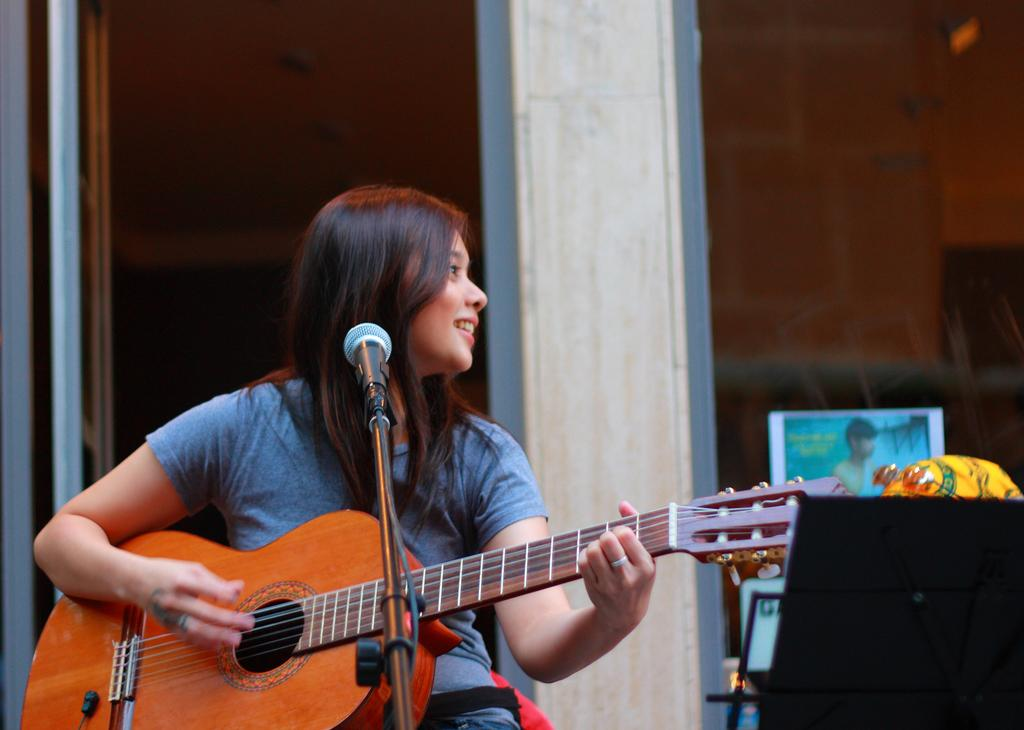Who is the main subject in the image? There is a woman in the image. What is the woman doing in the image? The woman is playing a guitar. What object is in front of the woman? There is a microphone in front of the woman. What expression does the woman have in the image? The woman is smiling. What type of skin condition can be seen on the woman's face in the image? There is no indication of any skin condition on the woman's face in the image. Can you tell me how many rifles are visible in the image? There are no rifles present in the image. 